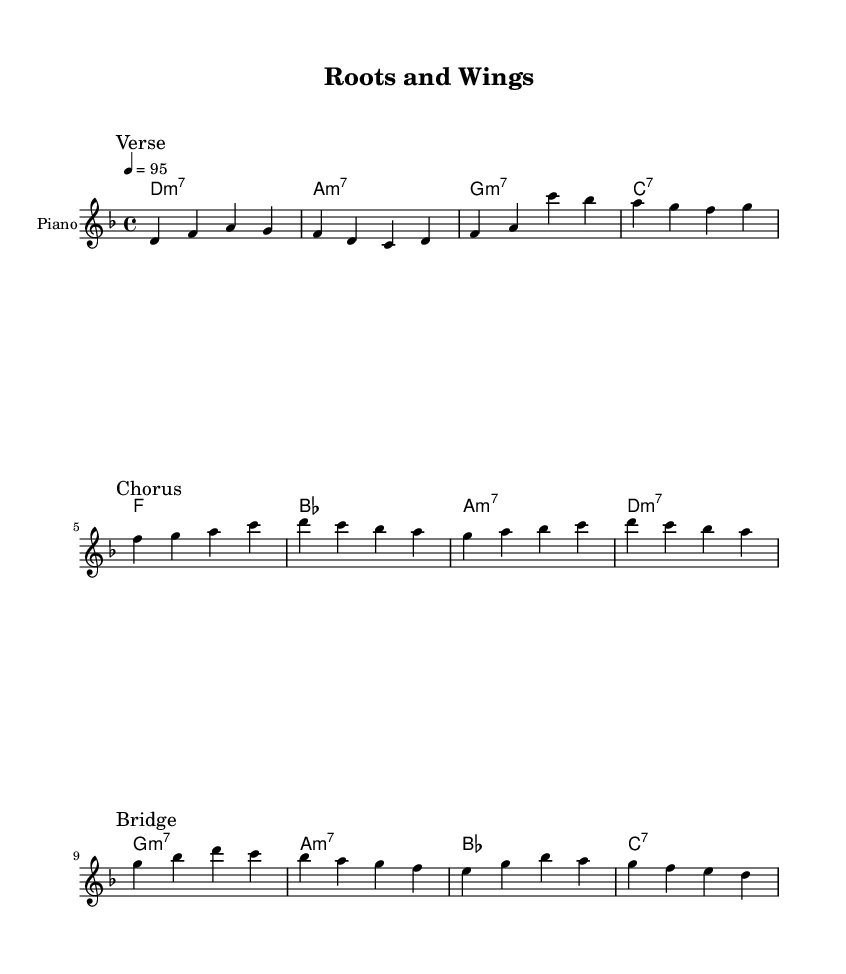What is the key signature of this music? The key signature is D minor, which has one flat (B flat) in the key signature. This can be determined by looking at the beginning of the sheet music, where the key signature is indicated.
Answer: D minor What is the time signature of this music? The time signature is 4/4, which means there are four beats in each measure and the quarter note gets one beat. This is also indicated at the beginning of the sheet music.
Answer: 4/4 What is the tempo marking of this piece? The tempo marking is 95 beats per minute, which is indicated by the number at the beginning of the score next to the word "tempo". It specifies how fast the music should be played.
Answer: 95 How many measures are in the "Chorus" section? The "Chorus" section contains four measures, which can be counted by looking at the number of grouped notes between the marked lines in that section of the music.
Answer: 4 What type of chords predominates the "Verse" section? The "Verse" section predominantly features minor 7th chords, as indicated by the chord symbols above the melody. These chords are denoted with "m7" in the chord symbols for each measure in that section.
Answer: minor 7th In which section does the melody begin to change key? The melody begins to change key in the "Bridge" section, which introduces different chord changes and melodic notes that are distinct from the "Verse" and "Chorus". The different chord structure hints at a key deviation.
Answer: Bridge What is the stylistic influence of this piece reflected in its music type? The piece reflects a modern neo-soul influence, characterized by smooth melodies, complex harmonies, and emotional expressions related to cultural heritage and rural development. This is evident in the overall structure and feel of the music.
Answer: modern neo-soul 